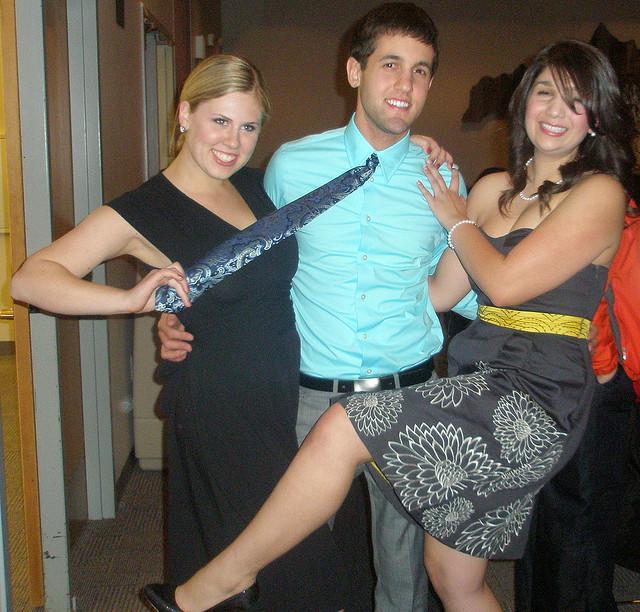Why is he holding a sword?
Keep it brief. He's not. Are the people in the photo having a good time?
Write a very short answer. Yes. What are the two women doing?
Short answer required. Posing. What is the girl pulling on?
Keep it brief. Tie. 